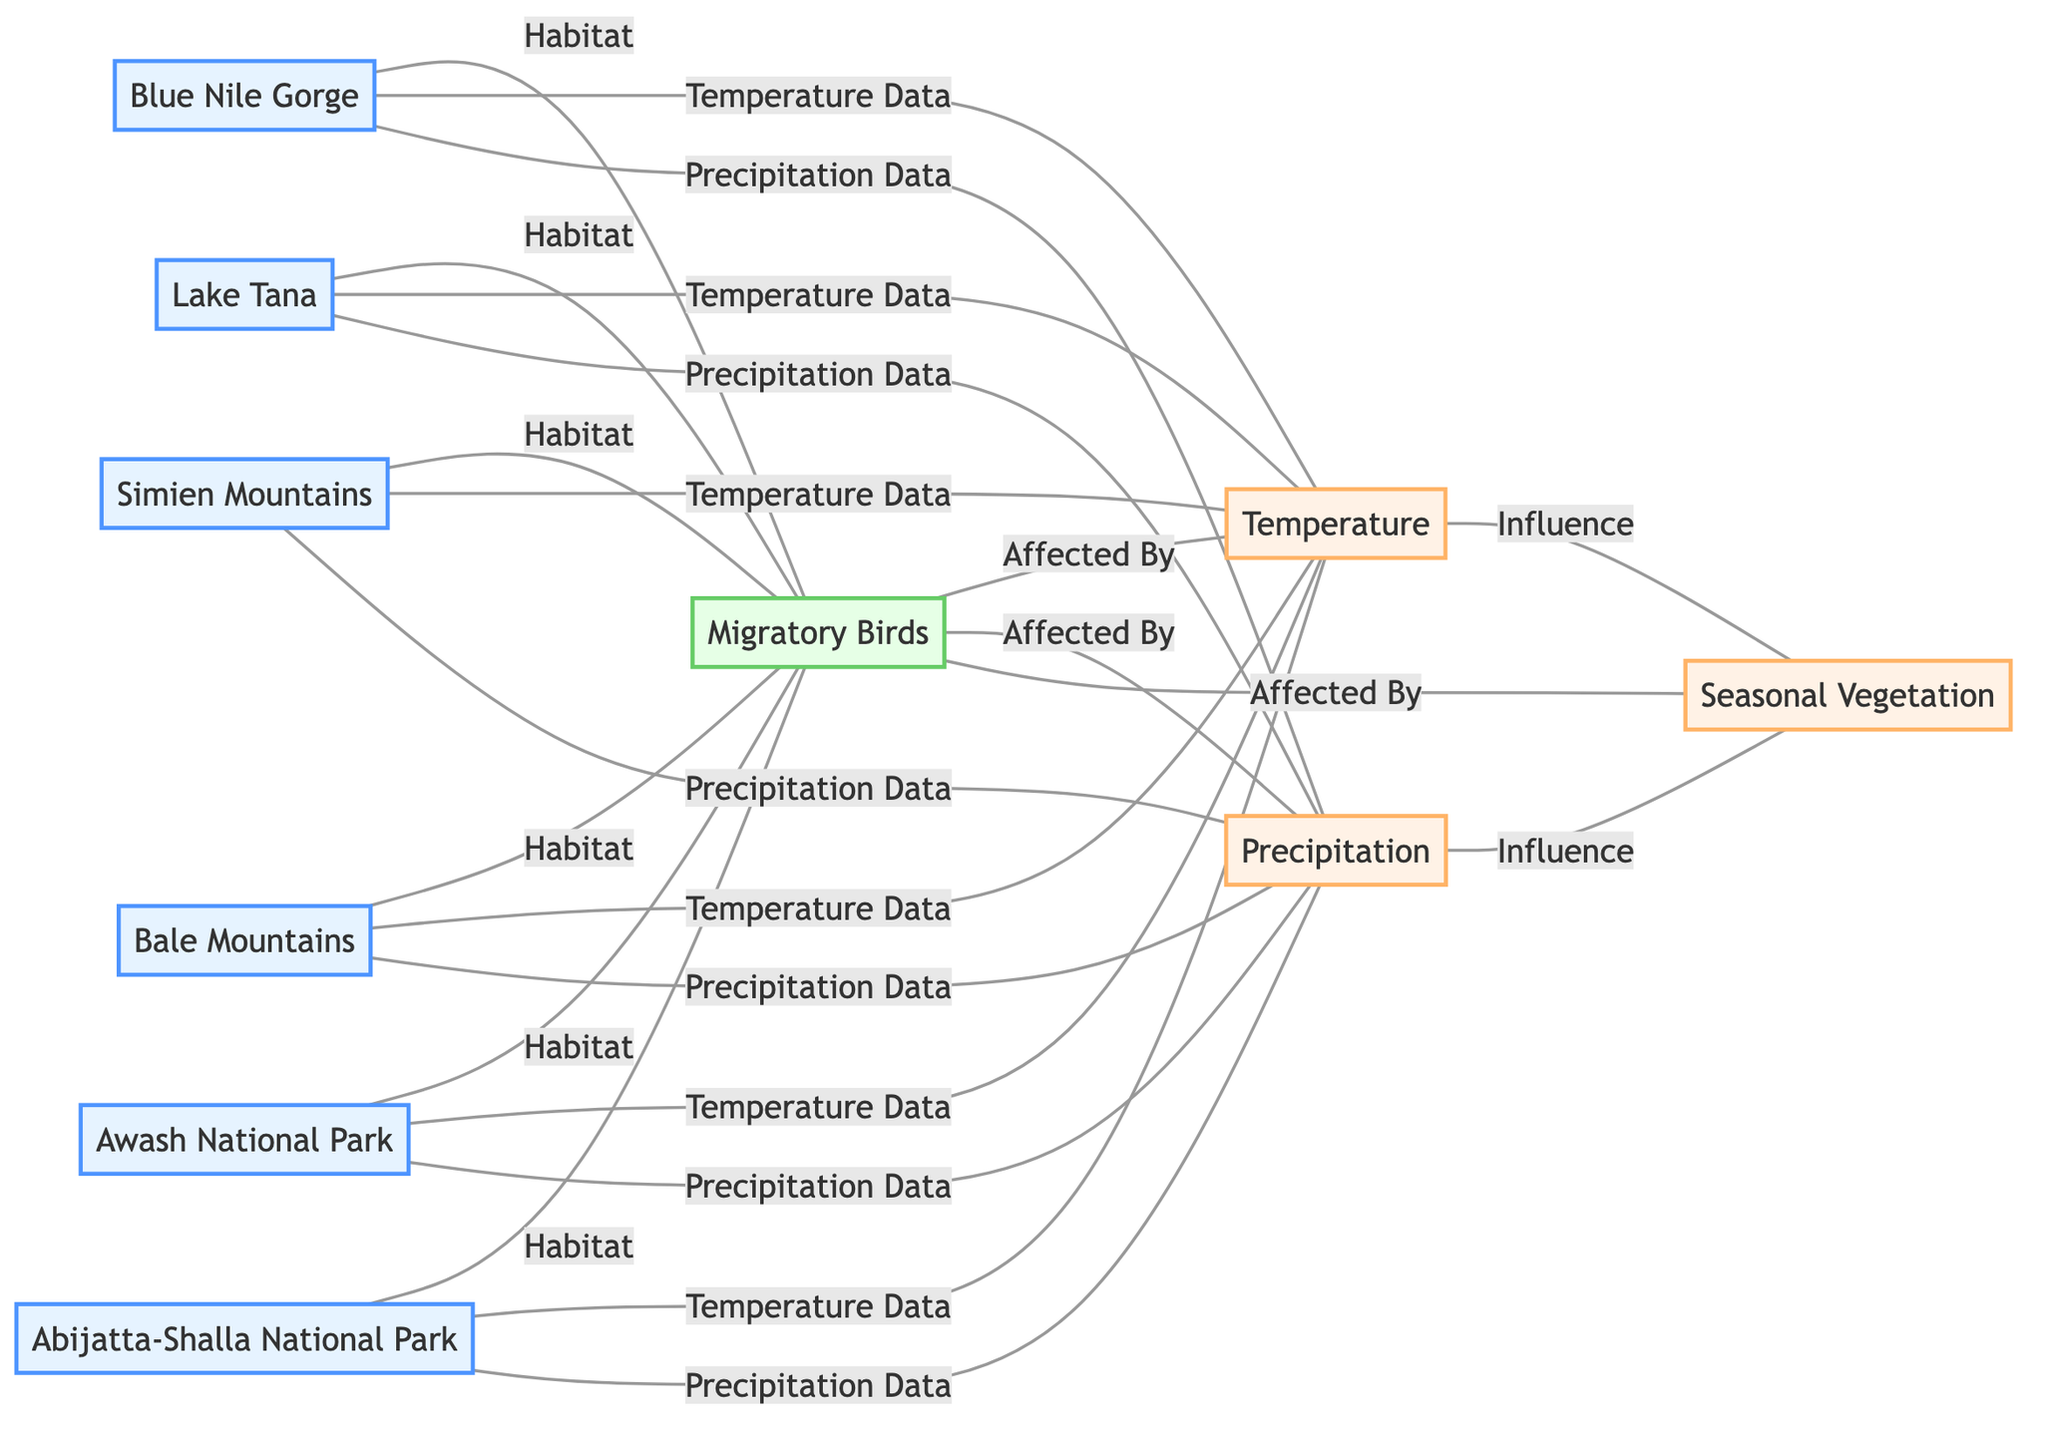What nodes are connected to the Migratory Birds? The nodes connected to "Migratory Birds" include "Blue Nile Gorge," "Lake Tana," "Simien Mountains," "Bale Mountains," "Awash National Park," and "Abijatta-Shalla National Park," which indicate the different habitats supporting these birds.
Answer: Blue Nile Gorge, Lake Tana, Simien Mountains, Bale Mountains, Awash National Park, Abijatta-Shalla National Park How many habitats are shown in the diagram? There are six habitats listed in the diagram, represented by the nodes connected to "Migratory Birds." These habitats are important locations for the migration of birds within Ethiopia.
Answer: 6 What are the environmental factors that affect migratory birds? The environmental factors affecting migratory birds are "Temperature," "Precipitation," and "Seasonal Vegetation," indicating the climatic and ecological conditions influencing their migration patterns.
Answer: Temperature, Precipitation, Seasonal Vegetation Which habitat is linked to both Temperature and Precipitation? All six habitats ("Blue Nile Gorge," "Lake Tana," "Simien Mountains," "Bale Mountains," "Awash National Park," "Abijatta-Shalla National Park") are connected to both Temperature and Precipitation, as they provide relevant environmental data for understanding the migratory patterns of birds.
Answer: All habitats What influences Seasonal Vegetation according to the diagram? Seasonal Vegetation is influenced by both Temperature and Precipitation, as indicated by the connections in the diagram, showing how these climatic conditions affect vegetation patterns in the region.
Answer: Temperature, Precipitation How many edges are there related to Temperature data? There are six edges that relate Temperature data to the habitats indicated, as these connections signify the temperature readings associated with each habitat.
Answer: 6 What label connects Lake Tana and Migratory Birds? The label connecting "Lake Tana" and "Migratory Birds" is "Habitat," indicating that the lake serves as an important habitat for various migratory bird species in Ethiopia.
Answer: Habitat Which two environmental factors influence Seasonal Vegetation? The two environmental factors that influence Seasonal Vegetation are "Temperature" and "Precipitation," as both play critical roles in determining the growth and cyclic nature of vegetation in the region.
Answer: Temperature, Precipitation What specific type of graph is utilized in this diagram? The graph type utilized in this diagram is an "Undirected Graph," which demonstrates the relationships and connections between different nodes without implying a direction in the associations.
Answer: Undirected Graph 